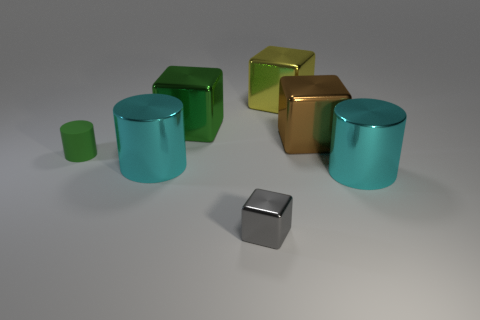What could be the purpose of arranging these objects like this? This arrangement may serve a decorative purpose or could be part of a product display. Alternatively, it might have been set up for a visual study comparing the objects' shapes and colors. Could it represent some sort of pattern? Yes, the deliberate spacing and selection of shapes and colors could represent an aesthetic pattern or convey an artistic message. The pattern emphasizes symmetry and balance. 